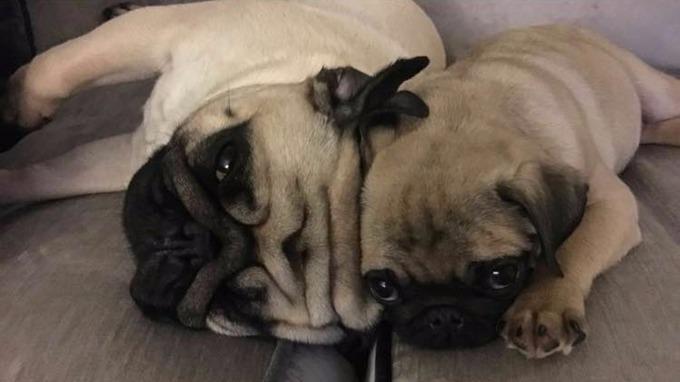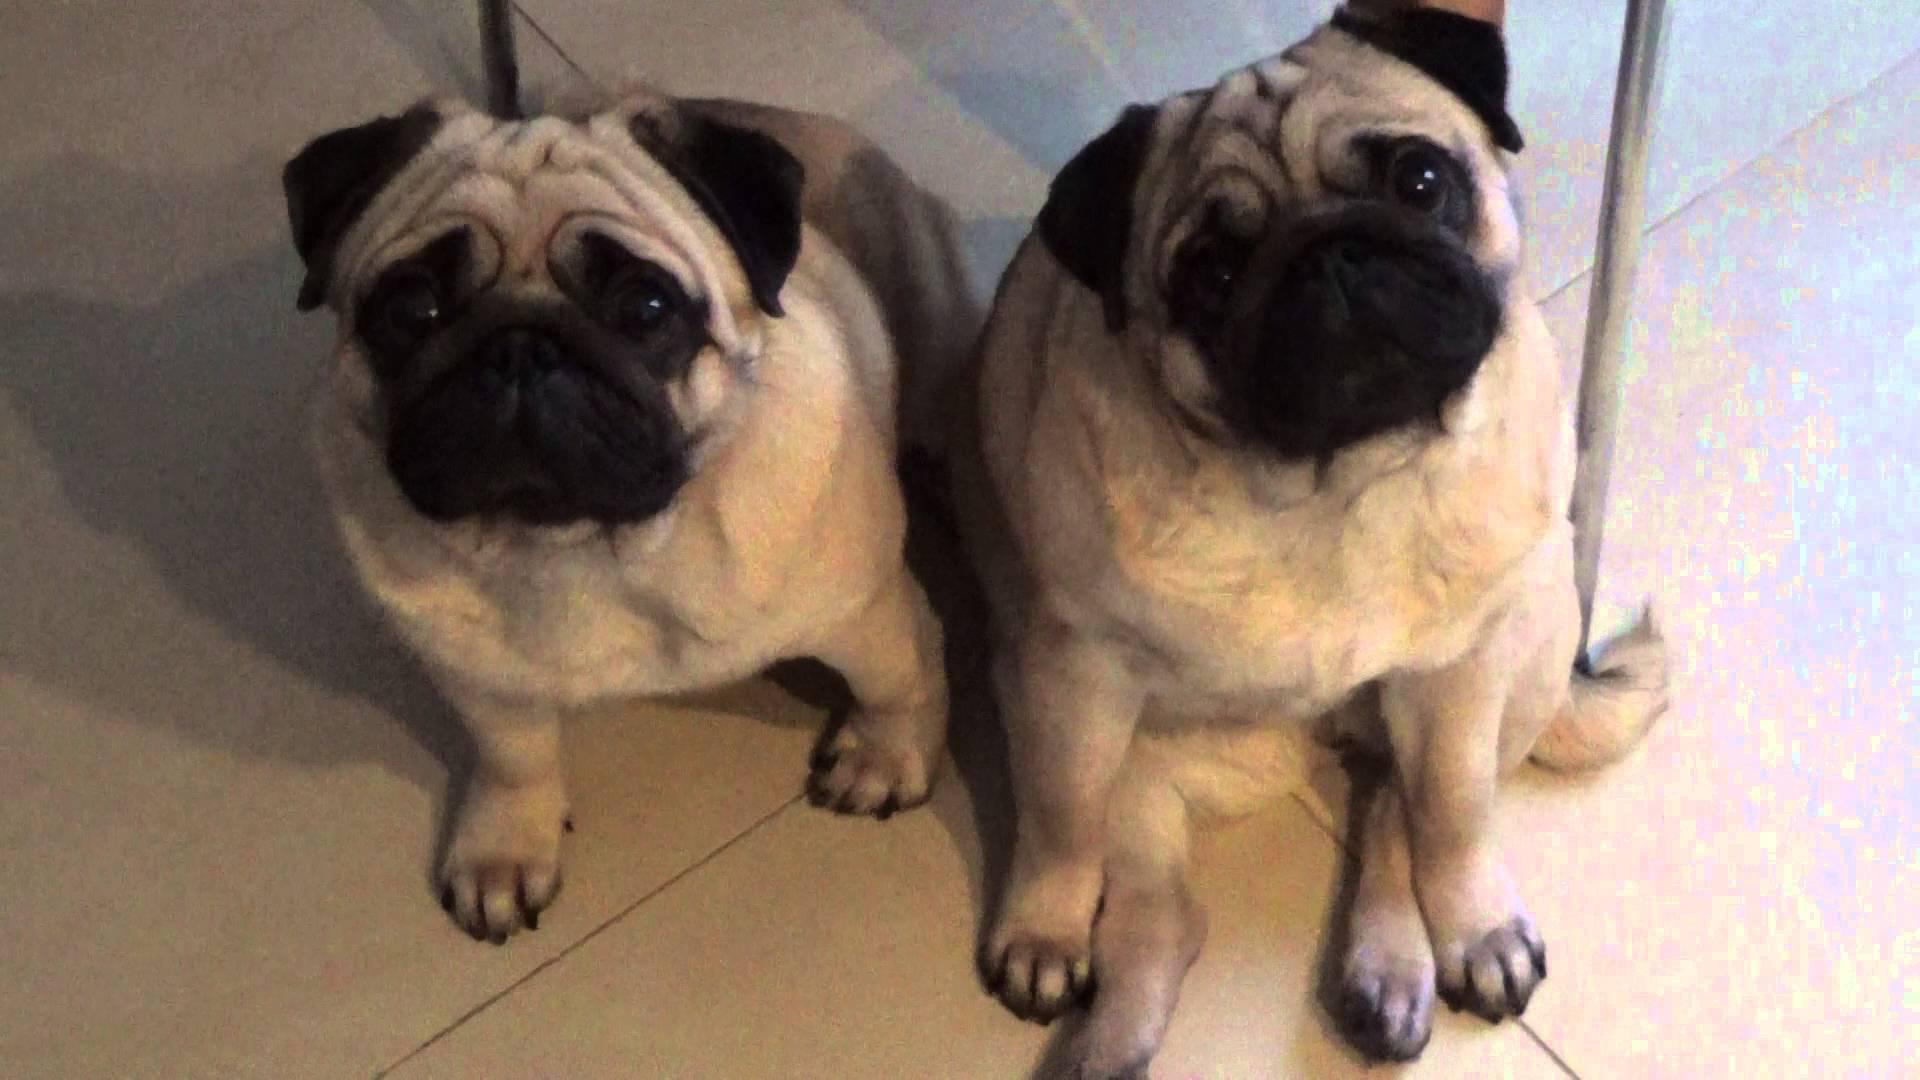The first image is the image on the left, the second image is the image on the right. For the images displayed, is the sentence "Each image in the pair has two pugs touching each other." factually correct? Answer yes or no. Yes. The first image is the image on the left, the second image is the image on the right. For the images shown, is this caption "There is exactly one pug in at least one image." true? Answer yes or no. No. 